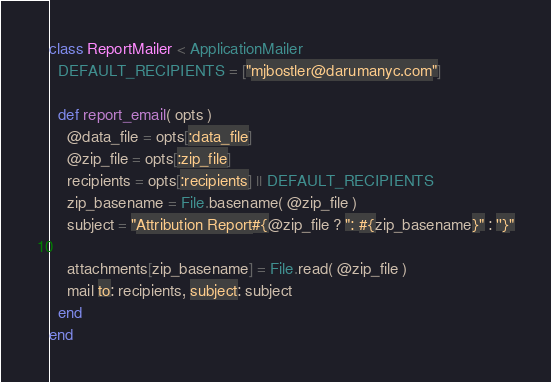<code> <loc_0><loc_0><loc_500><loc_500><_Ruby_>class ReportMailer < ApplicationMailer
  DEFAULT_RECIPIENTS = ["mjbostler@darumanyc.com"]
  
  def report_email( opts )
    @data_file = opts[:data_file]
    @zip_file = opts[:zip_file]
    recipients = opts[:recipients] || DEFAULT_RECIPIENTS
    zip_basename = File.basename( @zip_file )
    subject = "Attribution Report#{@zip_file ? ": #{zip_basename}" : ''}"
    
    attachments[zip_basename] = File.read( @zip_file )
    mail to: recipients, subject: subject
  end
end
</code> 